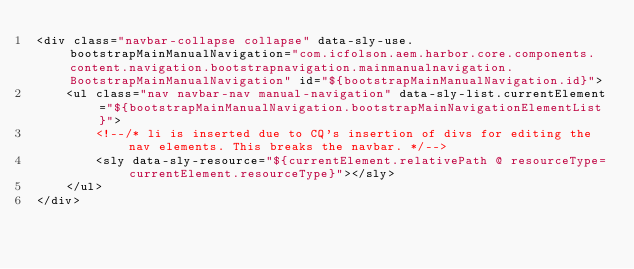Convert code to text. <code><loc_0><loc_0><loc_500><loc_500><_HTML_><div class="navbar-collapse collapse" data-sly-use.bootstrapMainManualNavigation="com.icfolson.aem.harbor.core.components.content.navigation.bootstrapnavigation.mainmanualnavigation.BootstrapMainManualNavigation" id="${bootstrapMainManualNavigation.id}">
    <ul class="nav navbar-nav manual-navigation" data-sly-list.currentElement="${bootstrapMainManualNavigation.bootstrapMainNavigationElementList}">
        <!--/* li is inserted due to CQ's insertion of divs for editing the nav elements. This breaks the navbar. */-->
        <sly data-sly-resource="${currentElement.relativePath @ resourceType=currentElement.resourceType}"></sly>
    </ul>
</div></code> 